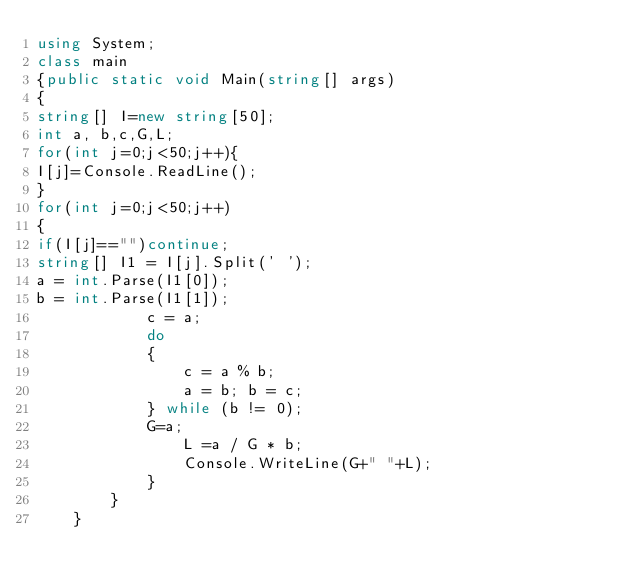<code> <loc_0><loc_0><loc_500><loc_500><_C#_>using System;
class main
{public static void Main(string[] args)
{
string[] I=new string[50];
int a, b,c,G,L;
for(int j=0;j<50;j++){
I[j]=Console.ReadLine();
}
for(int j=0;j<50;j++)
{
if(I[j]=="")continue;
string[] I1 = I[j].Split(' ');
a = int.Parse(I1[0]);
b = int.Parse(I1[1]);
            c = a;
            do
            {
                c = a % b;
                a = b; b = c;
            } while (b != 0);
            G=a;
                L =a / G * b;
                Console.WriteLine(G+" "+L);
            }
        }
    }</code> 